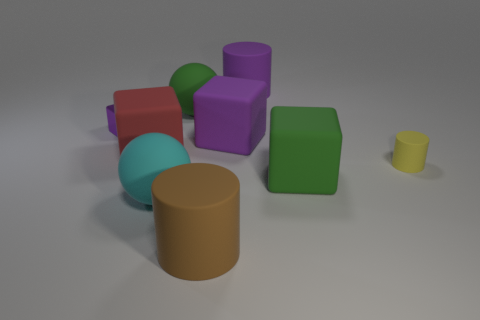Is the cyan matte object the same shape as the tiny metallic thing?
Your answer should be compact. No. How many spheres are either green things or cyan rubber objects?
Give a very brief answer. 2. What is the color of the tiny cylinder that is the same material as the big cyan ball?
Your answer should be compact. Yellow. There is a purple cube behind the purple matte cube; is it the same size as the large brown cylinder?
Offer a very short reply. No. Do the tiny yellow cylinder and the block right of the big purple rubber cylinder have the same material?
Keep it short and to the point. Yes. What color is the large matte cylinder behind the tiny purple cube?
Provide a succinct answer. Purple. Is there a large block that is to the right of the large green object to the left of the brown cylinder?
Offer a terse response. Yes. There is a large cylinder that is behind the small purple object; is its color the same as the small thing to the left of the green rubber ball?
Provide a short and direct response. Yes. How many purple cubes are on the right side of the large cyan rubber object?
Give a very brief answer. 1. What number of metal cubes have the same color as the metallic thing?
Ensure brevity in your answer.  0. 